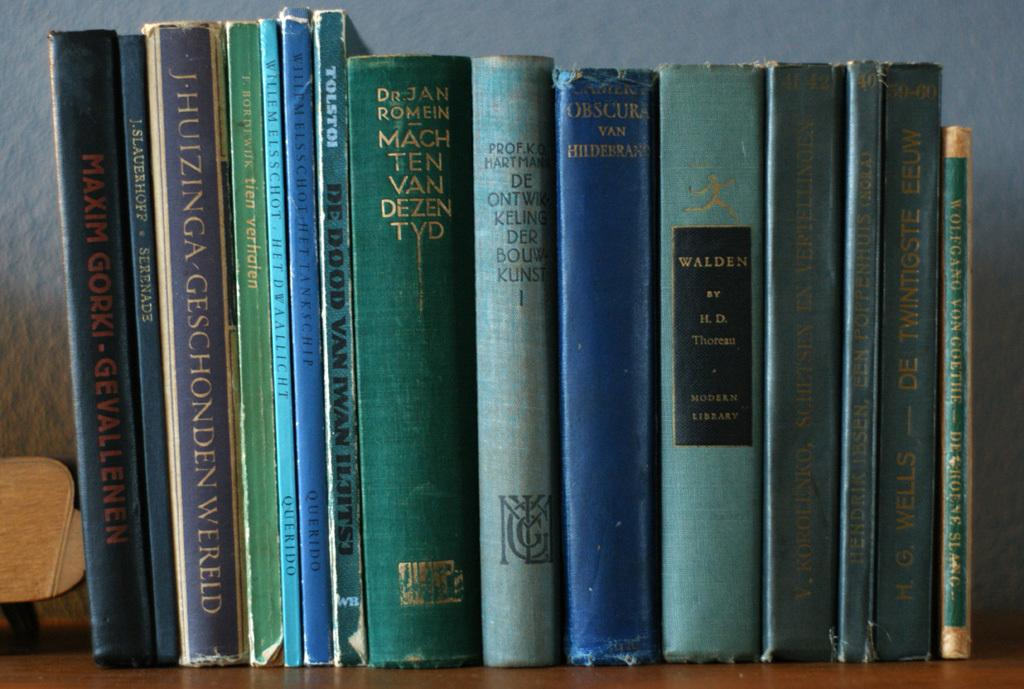<image>
Give a short and clear explanation of the subsequent image. A collection of books on a shelf includes the title Walden by H.D. Thoreau. 